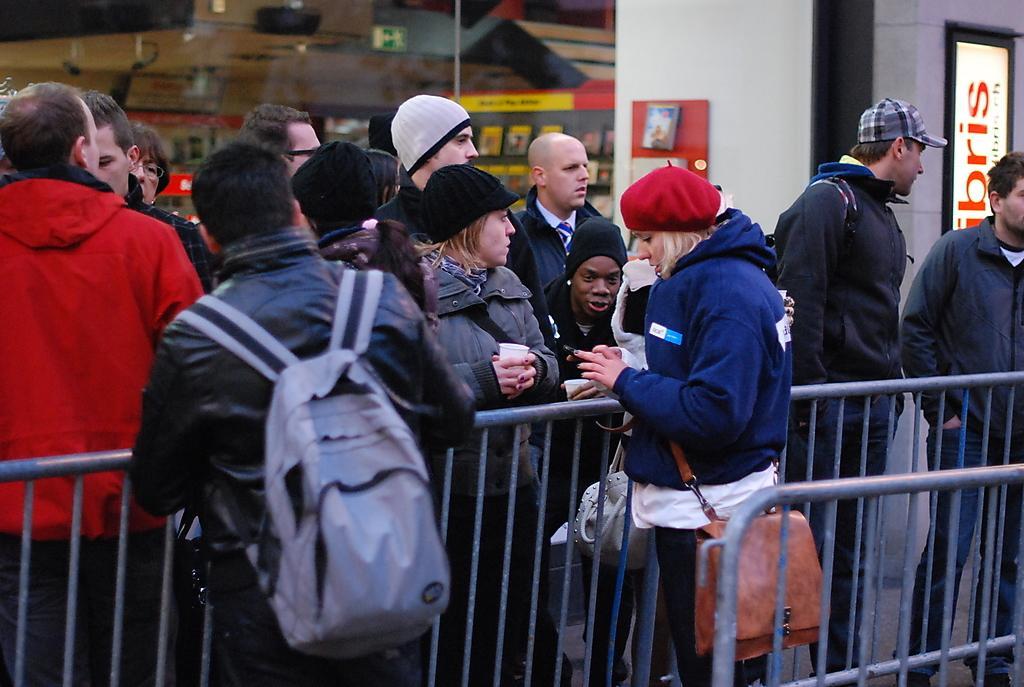Describe this image in one or two sentences. In this image there are group of people who are standing beside the fence. There are two people who are wearing the bag are standing in the middle. In the background there is a building with the glasses. On the right side top there is a hoarding. 